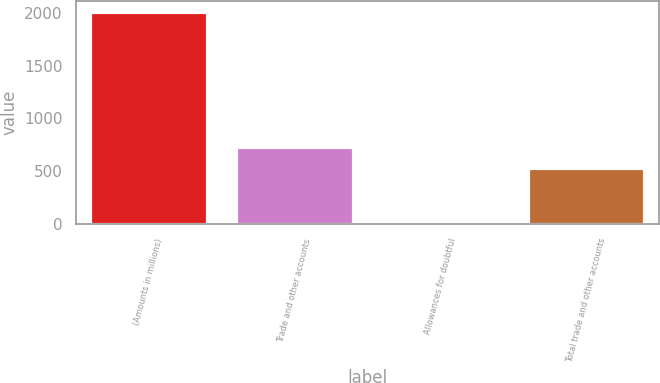Convert chart to OTSL. <chart><loc_0><loc_0><loc_500><loc_500><bar_chart><fcel>(Amounts in millions)<fcel>Trade and other accounts<fcel>Allowances for doubtful<fcel>Total trade and other accounts<nl><fcel>2013<fcel>731.41<fcel>14.9<fcel>531.6<nl></chart> 